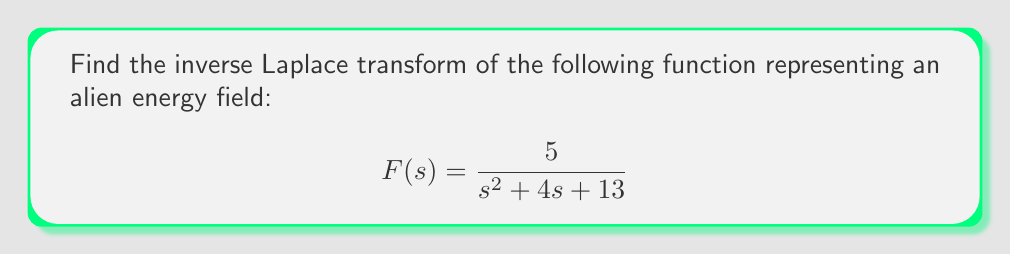Can you answer this question? To find the inverse Laplace transform, we need to recognize this as a standard form and use the appropriate formula. The given function is in the form:

$$\frac{A}{(s-a)^2 + b^2}$$

Where $A = 5$, $a = -2$, and $b = 3$.

The inverse Laplace transform of this form is:

$$\mathcal{L}^{-1}\left\{\frac{A}{(s-a)^2 + b^2}\right\} = \frac{A}{b}e^{at}\sin(bt)$$

Substituting our values:

$$\mathcal{L}^{-1}\left\{\frac{5}{s^2 + 4s + 13}\right\} = \frac{5}{3}e^{-2t}\sin(3t)$$

This function represents the time-domain behavior of the alien energy field.
Answer: $$f(t) = \frac{5}{3}e^{-2t}\sin(3t)$$ 